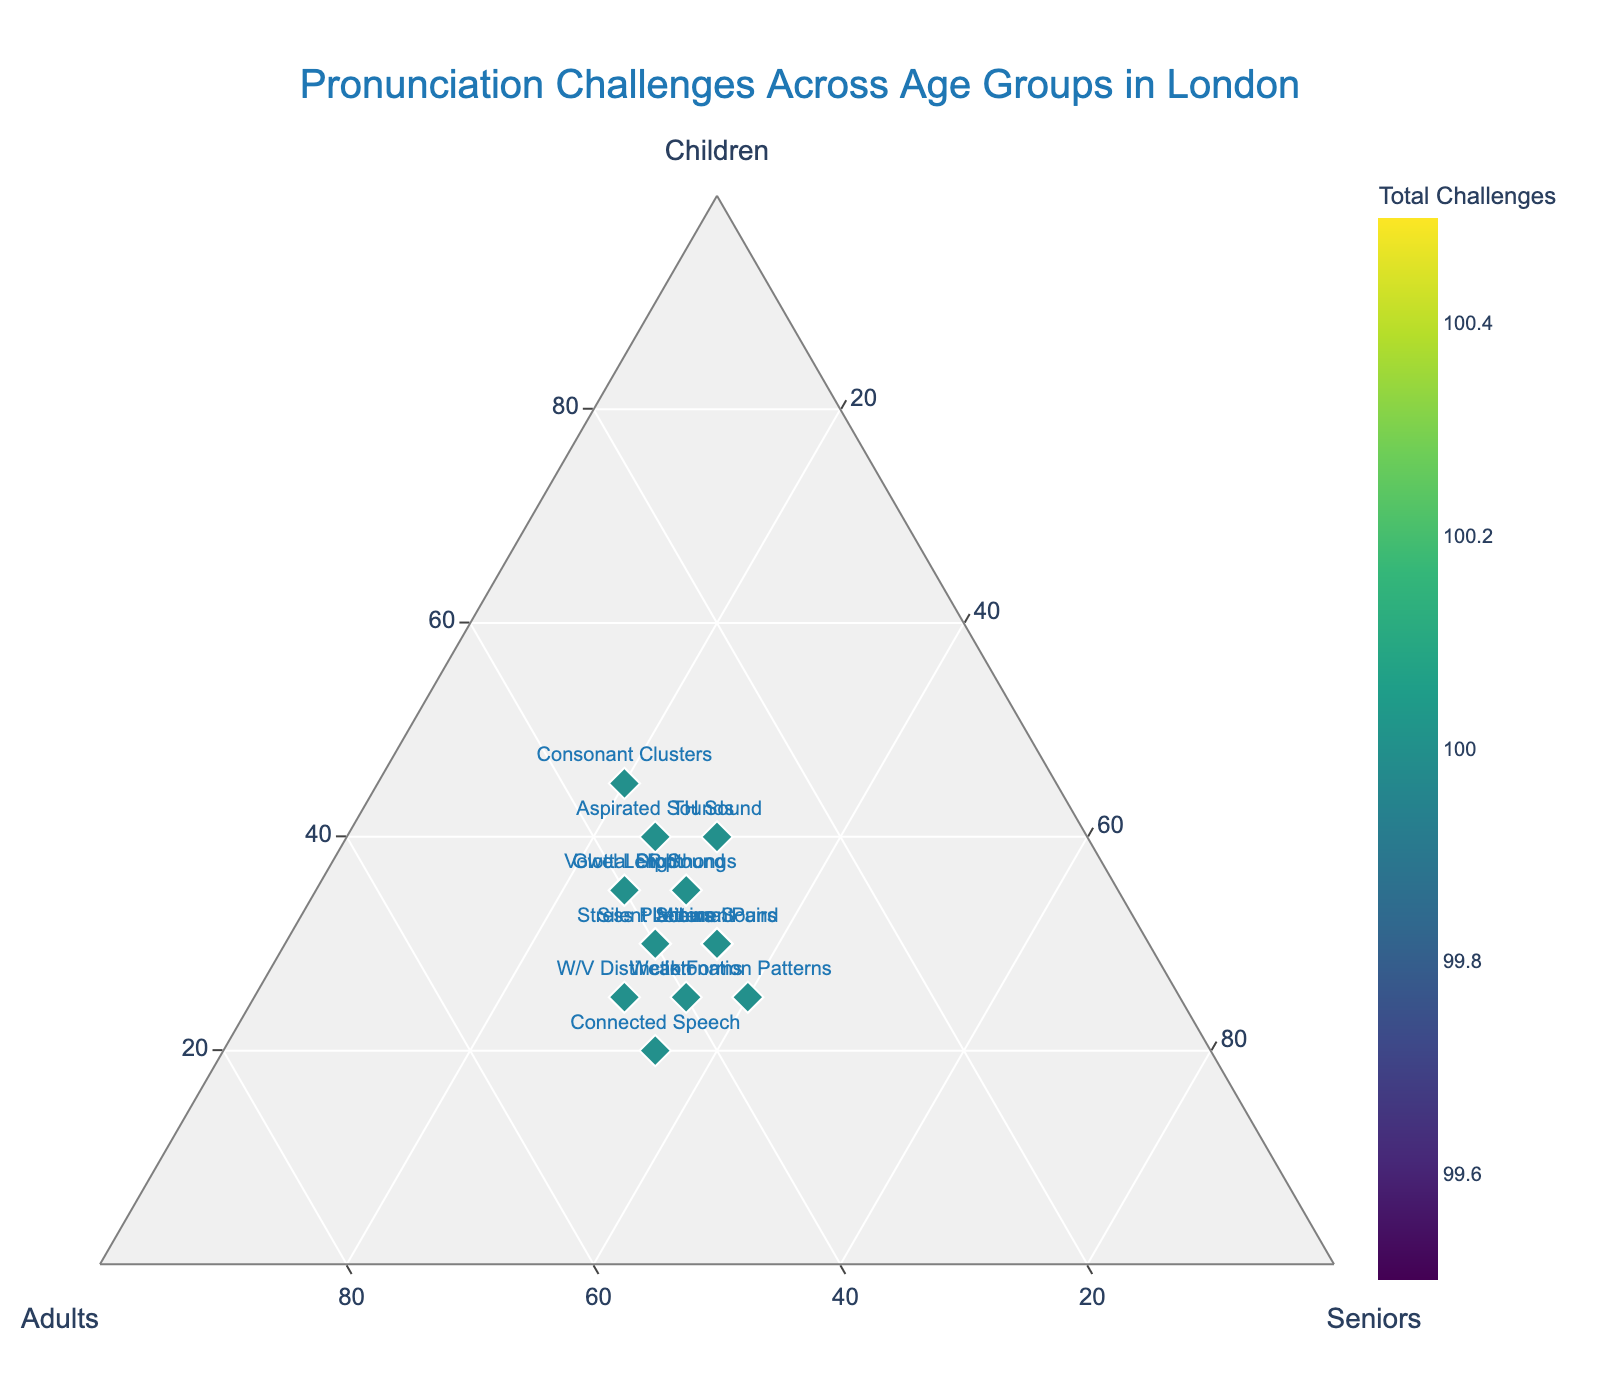What's the title of the figure? The title is usually found at the top center of the figure. In this case, it states "Pronunciation Challenges Across Age Groups in London".
Answer: "Pronunciation Challenges Across Age Groups in London" What does the children’s axis represent? Each axis in a ternary plot represents one of the three components being analyzed. The children’s axis represents the percentage of pronunciation challenges experienced by children.
Answer: Percentage of pronunciation challenges experienced by children Which age group represents the highest challenge for consonant clusters? From the ternary plot, the data point for Consonant Clusters shows the proportions of challenges. Children have the highest value, indicating they face the greatest challenge with consonant clusters.
Answer: Children What is the range of values on the color bar? The color bar on the right side of the plot is used to represent the total count of pronunciation challenges. By looking at the plot, the color bar ranges from 70 to 100.
Answer: 70 to 100 What is the percentage distribution of the ‘W/V Distinction’ challenge across the three age groups? Refer to the position of the W/V Distinction point on the ternary plot. The hover text shows 25% for Children, 45% for Adults, and 30% for Seniors.
Answer: 25% Children, 45% Adults, 30% Seniors Which pronunciation challenge is most evenly distributed among all age groups? To find the most evenly distributed challenge, look for the point that is closest to the center of the plot. This means the percentages for Children, Adults, and Seniors should be nearly equal. Here, R Sound has the values 35%, 35%, and 30%, which is quite balanced.
Answer: R Sound How does the 'TH Sound' challenge compare for adults and seniors? The percentage distribution in the plot shows that both Adults and Seniors have the same challenge level for the TH Sound, which is 30%.
Answer: Equal (30% each) Which age group has fewer challenges with 'Aspirated Sounds' compared to 'Silent Letters'? By comparing the normalized percentages for both points, for 'Aspirated Sounds,' Children have 40%, Adults 35%, and Seniors 25%. For 'Silent Letters,' Children have 30%, Adults 40%, and Seniors 30%. Thus, Seniors face fewer challenges with Aspirated Sounds compared to Silent Letters.
Answer: Seniors What is the percentage difference between children and seniors for the 'Glottal Stop' challenge? The percentages from the plot are 35% for Children and 25% for Seniors. The difference is calculated as 35% - 25% = 10%.
Answer: 10% What does the color of the data points represent? The color mapping in the ternary plot indicates the total number of pronunciation challenges each data point represents. Colors vary from lighter to darker shades based on the total values.
Answer: Total number of pronunciation challenges 